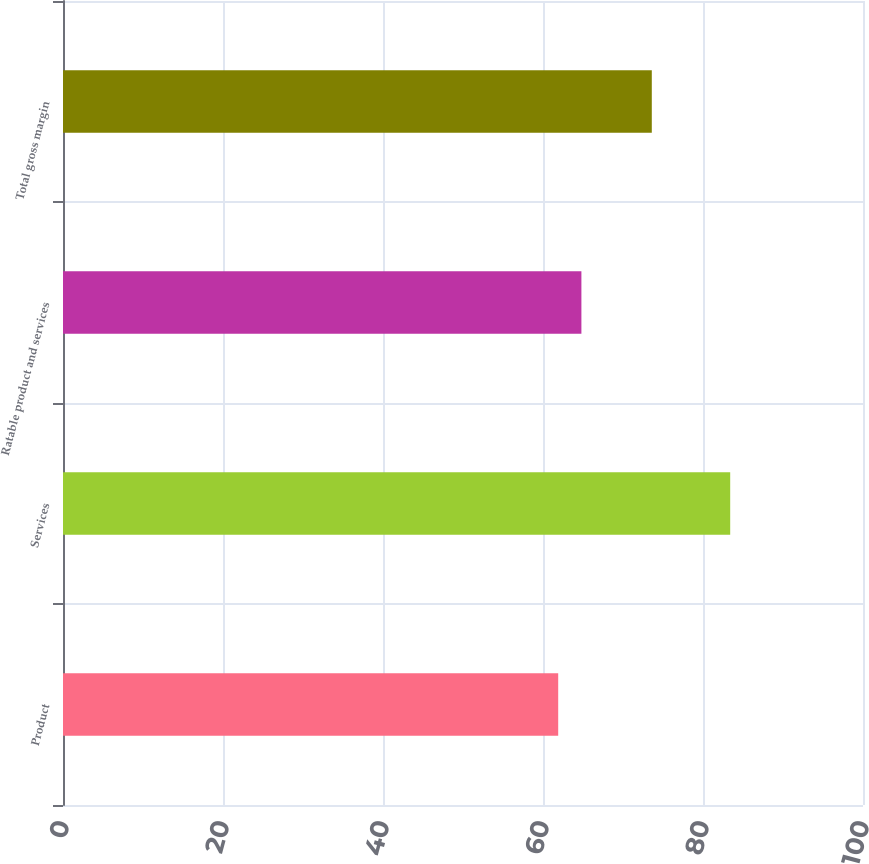Convert chart. <chart><loc_0><loc_0><loc_500><loc_500><bar_chart><fcel>Product<fcel>Services<fcel>Ratable product and services<fcel>Total gross margin<nl><fcel>61.9<fcel>83.4<fcel>64.8<fcel>73.6<nl></chart> 